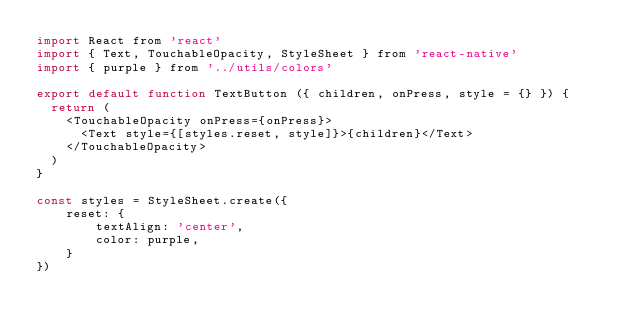Convert code to text. <code><loc_0><loc_0><loc_500><loc_500><_JavaScript_>import React from 'react'
import { Text, TouchableOpacity, StyleSheet } from 'react-native'
import { purple } from '../utils/colors'

export default function TextButton ({ children, onPress, style = {} }) {
  return (
    <TouchableOpacity onPress={onPress}>
      <Text style={[styles.reset, style]}>{children}</Text>
    </TouchableOpacity>
  )
} 

const styles = StyleSheet.create({
    reset: {
        textAlign: 'center',
        color: purple,
    }
})</code> 